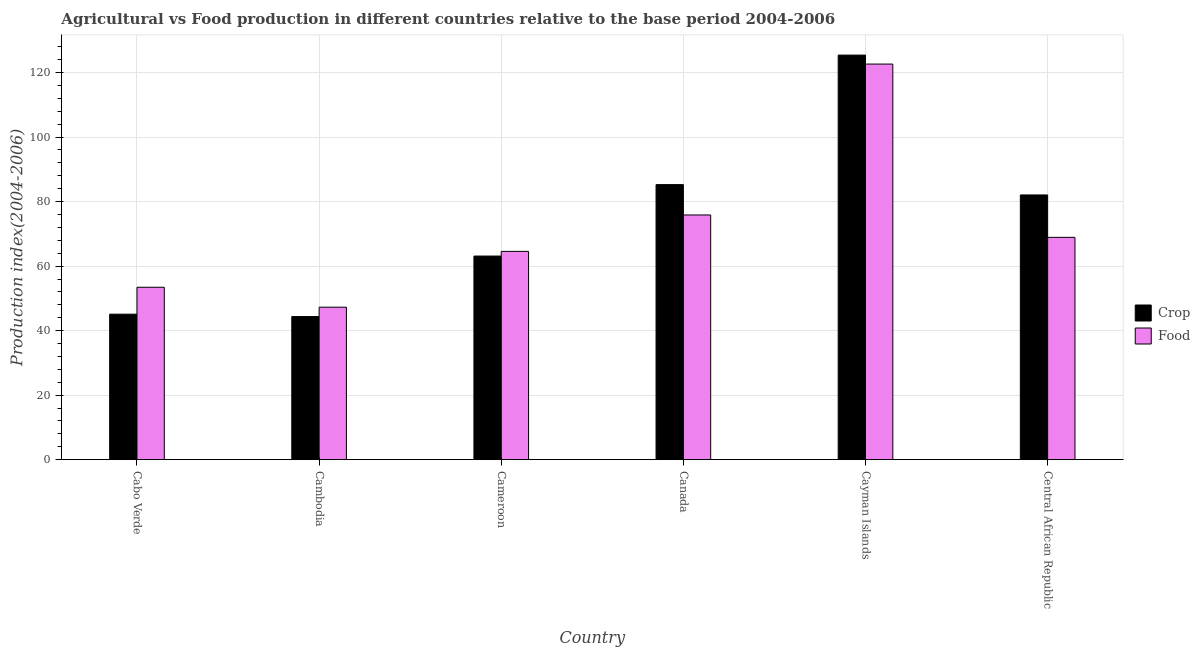How many groups of bars are there?
Make the answer very short. 6. Are the number of bars per tick equal to the number of legend labels?
Your answer should be very brief. Yes. Are the number of bars on each tick of the X-axis equal?
Your answer should be very brief. Yes. What is the label of the 1st group of bars from the left?
Offer a terse response. Cabo Verde. What is the food production index in Canada?
Provide a succinct answer. 75.85. Across all countries, what is the maximum crop production index?
Your answer should be very brief. 125.39. Across all countries, what is the minimum crop production index?
Ensure brevity in your answer.  44.36. In which country was the food production index maximum?
Your answer should be very brief. Cayman Islands. In which country was the food production index minimum?
Make the answer very short. Cambodia. What is the total crop production index in the graph?
Make the answer very short. 445.26. What is the difference between the food production index in Cambodia and that in Cameroon?
Offer a very short reply. -17.29. What is the difference between the food production index in Cambodia and the crop production index in Cabo Verde?
Make the answer very short. 2.17. What is the average crop production index per country?
Offer a terse response. 74.21. What is the difference between the crop production index and food production index in Cameroon?
Make the answer very short. -1.45. In how many countries, is the food production index greater than 24 ?
Make the answer very short. 6. What is the ratio of the food production index in Cambodia to that in Canada?
Your answer should be very brief. 0.62. Is the difference between the food production index in Cabo Verde and Central African Republic greater than the difference between the crop production index in Cabo Verde and Central African Republic?
Your response must be concise. Yes. What is the difference between the highest and the second highest crop production index?
Offer a terse response. 40.14. What is the difference between the highest and the lowest crop production index?
Give a very brief answer. 81.03. Is the sum of the food production index in Cabo Verde and Cayman Islands greater than the maximum crop production index across all countries?
Your response must be concise. Yes. What does the 1st bar from the left in Canada represents?
Provide a succinct answer. Crop. What does the 1st bar from the right in Central African Republic represents?
Give a very brief answer. Food. Are all the bars in the graph horizontal?
Your answer should be compact. No. Are the values on the major ticks of Y-axis written in scientific E-notation?
Your response must be concise. No. Does the graph contain any zero values?
Keep it short and to the point. No. Does the graph contain grids?
Your answer should be very brief. Yes. How are the legend labels stacked?
Give a very brief answer. Vertical. What is the title of the graph?
Offer a very short reply. Agricultural vs Food production in different countries relative to the base period 2004-2006. Does "Under-5(female)" appear as one of the legend labels in the graph?
Offer a very short reply. No. What is the label or title of the Y-axis?
Provide a short and direct response. Production index(2004-2006). What is the Production index(2004-2006) in Crop in Cabo Verde?
Your response must be concise. 45.1. What is the Production index(2004-2006) in Food in Cabo Verde?
Keep it short and to the point. 53.44. What is the Production index(2004-2006) in Crop in Cambodia?
Provide a succinct answer. 44.36. What is the Production index(2004-2006) of Food in Cambodia?
Keep it short and to the point. 47.27. What is the Production index(2004-2006) of Crop in Cameroon?
Offer a terse response. 63.11. What is the Production index(2004-2006) in Food in Cameroon?
Your response must be concise. 64.56. What is the Production index(2004-2006) of Crop in Canada?
Provide a short and direct response. 85.25. What is the Production index(2004-2006) of Food in Canada?
Ensure brevity in your answer.  75.85. What is the Production index(2004-2006) of Crop in Cayman Islands?
Ensure brevity in your answer.  125.39. What is the Production index(2004-2006) in Food in Cayman Islands?
Provide a short and direct response. 122.61. What is the Production index(2004-2006) of Crop in Central African Republic?
Your answer should be very brief. 82.05. What is the Production index(2004-2006) of Food in Central African Republic?
Ensure brevity in your answer.  68.91. Across all countries, what is the maximum Production index(2004-2006) of Crop?
Your answer should be very brief. 125.39. Across all countries, what is the maximum Production index(2004-2006) of Food?
Provide a succinct answer. 122.61. Across all countries, what is the minimum Production index(2004-2006) of Crop?
Give a very brief answer. 44.36. Across all countries, what is the minimum Production index(2004-2006) of Food?
Your answer should be very brief. 47.27. What is the total Production index(2004-2006) in Crop in the graph?
Ensure brevity in your answer.  445.26. What is the total Production index(2004-2006) in Food in the graph?
Keep it short and to the point. 432.64. What is the difference between the Production index(2004-2006) in Crop in Cabo Verde and that in Cambodia?
Your answer should be compact. 0.74. What is the difference between the Production index(2004-2006) in Food in Cabo Verde and that in Cambodia?
Your answer should be very brief. 6.17. What is the difference between the Production index(2004-2006) of Crop in Cabo Verde and that in Cameroon?
Keep it short and to the point. -18.01. What is the difference between the Production index(2004-2006) of Food in Cabo Verde and that in Cameroon?
Keep it short and to the point. -11.12. What is the difference between the Production index(2004-2006) in Crop in Cabo Verde and that in Canada?
Keep it short and to the point. -40.15. What is the difference between the Production index(2004-2006) in Food in Cabo Verde and that in Canada?
Offer a very short reply. -22.41. What is the difference between the Production index(2004-2006) in Crop in Cabo Verde and that in Cayman Islands?
Make the answer very short. -80.29. What is the difference between the Production index(2004-2006) in Food in Cabo Verde and that in Cayman Islands?
Provide a succinct answer. -69.17. What is the difference between the Production index(2004-2006) of Crop in Cabo Verde and that in Central African Republic?
Keep it short and to the point. -36.95. What is the difference between the Production index(2004-2006) of Food in Cabo Verde and that in Central African Republic?
Offer a terse response. -15.47. What is the difference between the Production index(2004-2006) in Crop in Cambodia and that in Cameroon?
Ensure brevity in your answer.  -18.75. What is the difference between the Production index(2004-2006) in Food in Cambodia and that in Cameroon?
Give a very brief answer. -17.29. What is the difference between the Production index(2004-2006) of Crop in Cambodia and that in Canada?
Offer a terse response. -40.89. What is the difference between the Production index(2004-2006) in Food in Cambodia and that in Canada?
Give a very brief answer. -28.58. What is the difference between the Production index(2004-2006) in Crop in Cambodia and that in Cayman Islands?
Your response must be concise. -81.03. What is the difference between the Production index(2004-2006) in Food in Cambodia and that in Cayman Islands?
Offer a very short reply. -75.34. What is the difference between the Production index(2004-2006) of Crop in Cambodia and that in Central African Republic?
Offer a terse response. -37.69. What is the difference between the Production index(2004-2006) in Food in Cambodia and that in Central African Republic?
Your answer should be very brief. -21.64. What is the difference between the Production index(2004-2006) in Crop in Cameroon and that in Canada?
Give a very brief answer. -22.14. What is the difference between the Production index(2004-2006) of Food in Cameroon and that in Canada?
Your answer should be very brief. -11.29. What is the difference between the Production index(2004-2006) in Crop in Cameroon and that in Cayman Islands?
Your answer should be compact. -62.28. What is the difference between the Production index(2004-2006) in Food in Cameroon and that in Cayman Islands?
Your answer should be very brief. -58.05. What is the difference between the Production index(2004-2006) of Crop in Cameroon and that in Central African Republic?
Ensure brevity in your answer.  -18.94. What is the difference between the Production index(2004-2006) in Food in Cameroon and that in Central African Republic?
Make the answer very short. -4.35. What is the difference between the Production index(2004-2006) in Crop in Canada and that in Cayman Islands?
Ensure brevity in your answer.  -40.14. What is the difference between the Production index(2004-2006) of Food in Canada and that in Cayman Islands?
Your response must be concise. -46.76. What is the difference between the Production index(2004-2006) in Food in Canada and that in Central African Republic?
Ensure brevity in your answer.  6.94. What is the difference between the Production index(2004-2006) in Crop in Cayman Islands and that in Central African Republic?
Ensure brevity in your answer.  43.34. What is the difference between the Production index(2004-2006) of Food in Cayman Islands and that in Central African Republic?
Ensure brevity in your answer.  53.7. What is the difference between the Production index(2004-2006) in Crop in Cabo Verde and the Production index(2004-2006) in Food in Cambodia?
Your answer should be compact. -2.17. What is the difference between the Production index(2004-2006) in Crop in Cabo Verde and the Production index(2004-2006) in Food in Cameroon?
Your answer should be very brief. -19.46. What is the difference between the Production index(2004-2006) in Crop in Cabo Verde and the Production index(2004-2006) in Food in Canada?
Offer a very short reply. -30.75. What is the difference between the Production index(2004-2006) in Crop in Cabo Verde and the Production index(2004-2006) in Food in Cayman Islands?
Ensure brevity in your answer.  -77.51. What is the difference between the Production index(2004-2006) in Crop in Cabo Verde and the Production index(2004-2006) in Food in Central African Republic?
Offer a very short reply. -23.81. What is the difference between the Production index(2004-2006) in Crop in Cambodia and the Production index(2004-2006) in Food in Cameroon?
Offer a very short reply. -20.2. What is the difference between the Production index(2004-2006) in Crop in Cambodia and the Production index(2004-2006) in Food in Canada?
Provide a succinct answer. -31.49. What is the difference between the Production index(2004-2006) of Crop in Cambodia and the Production index(2004-2006) of Food in Cayman Islands?
Offer a terse response. -78.25. What is the difference between the Production index(2004-2006) of Crop in Cambodia and the Production index(2004-2006) of Food in Central African Republic?
Offer a very short reply. -24.55. What is the difference between the Production index(2004-2006) of Crop in Cameroon and the Production index(2004-2006) of Food in Canada?
Give a very brief answer. -12.74. What is the difference between the Production index(2004-2006) of Crop in Cameroon and the Production index(2004-2006) of Food in Cayman Islands?
Keep it short and to the point. -59.5. What is the difference between the Production index(2004-2006) of Crop in Canada and the Production index(2004-2006) of Food in Cayman Islands?
Keep it short and to the point. -37.36. What is the difference between the Production index(2004-2006) of Crop in Canada and the Production index(2004-2006) of Food in Central African Republic?
Provide a succinct answer. 16.34. What is the difference between the Production index(2004-2006) of Crop in Cayman Islands and the Production index(2004-2006) of Food in Central African Republic?
Offer a terse response. 56.48. What is the average Production index(2004-2006) of Crop per country?
Your answer should be very brief. 74.21. What is the average Production index(2004-2006) in Food per country?
Ensure brevity in your answer.  72.11. What is the difference between the Production index(2004-2006) in Crop and Production index(2004-2006) in Food in Cabo Verde?
Offer a terse response. -8.34. What is the difference between the Production index(2004-2006) in Crop and Production index(2004-2006) in Food in Cambodia?
Your response must be concise. -2.91. What is the difference between the Production index(2004-2006) in Crop and Production index(2004-2006) in Food in Cameroon?
Your response must be concise. -1.45. What is the difference between the Production index(2004-2006) of Crop and Production index(2004-2006) of Food in Canada?
Offer a very short reply. 9.4. What is the difference between the Production index(2004-2006) in Crop and Production index(2004-2006) in Food in Cayman Islands?
Ensure brevity in your answer.  2.78. What is the difference between the Production index(2004-2006) of Crop and Production index(2004-2006) of Food in Central African Republic?
Keep it short and to the point. 13.14. What is the ratio of the Production index(2004-2006) of Crop in Cabo Verde to that in Cambodia?
Ensure brevity in your answer.  1.02. What is the ratio of the Production index(2004-2006) in Food in Cabo Verde to that in Cambodia?
Offer a terse response. 1.13. What is the ratio of the Production index(2004-2006) of Crop in Cabo Verde to that in Cameroon?
Your answer should be very brief. 0.71. What is the ratio of the Production index(2004-2006) in Food in Cabo Verde to that in Cameroon?
Ensure brevity in your answer.  0.83. What is the ratio of the Production index(2004-2006) in Crop in Cabo Verde to that in Canada?
Your response must be concise. 0.53. What is the ratio of the Production index(2004-2006) in Food in Cabo Verde to that in Canada?
Provide a short and direct response. 0.7. What is the ratio of the Production index(2004-2006) of Crop in Cabo Verde to that in Cayman Islands?
Your answer should be very brief. 0.36. What is the ratio of the Production index(2004-2006) in Food in Cabo Verde to that in Cayman Islands?
Offer a terse response. 0.44. What is the ratio of the Production index(2004-2006) of Crop in Cabo Verde to that in Central African Republic?
Keep it short and to the point. 0.55. What is the ratio of the Production index(2004-2006) of Food in Cabo Verde to that in Central African Republic?
Your answer should be compact. 0.78. What is the ratio of the Production index(2004-2006) in Crop in Cambodia to that in Cameroon?
Provide a short and direct response. 0.7. What is the ratio of the Production index(2004-2006) of Food in Cambodia to that in Cameroon?
Offer a terse response. 0.73. What is the ratio of the Production index(2004-2006) of Crop in Cambodia to that in Canada?
Provide a short and direct response. 0.52. What is the ratio of the Production index(2004-2006) of Food in Cambodia to that in Canada?
Your response must be concise. 0.62. What is the ratio of the Production index(2004-2006) of Crop in Cambodia to that in Cayman Islands?
Provide a succinct answer. 0.35. What is the ratio of the Production index(2004-2006) of Food in Cambodia to that in Cayman Islands?
Ensure brevity in your answer.  0.39. What is the ratio of the Production index(2004-2006) of Crop in Cambodia to that in Central African Republic?
Your answer should be very brief. 0.54. What is the ratio of the Production index(2004-2006) in Food in Cambodia to that in Central African Republic?
Keep it short and to the point. 0.69. What is the ratio of the Production index(2004-2006) in Crop in Cameroon to that in Canada?
Provide a short and direct response. 0.74. What is the ratio of the Production index(2004-2006) in Food in Cameroon to that in Canada?
Keep it short and to the point. 0.85. What is the ratio of the Production index(2004-2006) in Crop in Cameroon to that in Cayman Islands?
Give a very brief answer. 0.5. What is the ratio of the Production index(2004-2006) of Food in Cameroon to that in Cayman Islands?
Ensure brevity in your answer.  0.53. What is the ratio of the Production index(2004-2006) in Crop in Cameroon to that in Central African Republic?
Provide a succinct answer. 0.77. What is the ratio of the Production index(2004-2006) of Food in Cameroon to that in Central African Republic?
Provide a short and direct response. 0.94. What is the ratio of the Production index(2004-2006) in Crop in Canada to that in Cayman Islands?
Offer a terse response. 0.68. What is the ratio of the Production index(2004-2006) in Food in Canada to that in Cayman Islands?
Your answer should be compact. 0.62. What is the ratio of the Production index(2004-2006) of Crop in Canada to that in Central African Republic?
Your answer should be very brief. 1.04. What is the ratio of the Production index(2004-2006) of Food in Canada to that in Central African Republic?
Give a very brief answer. 1.1. What is the ratio of the Production index(2004-2006) in Crop in Cayman Islands to that in Central African Republic?
Offer a very short reply. 1.53. What is the ratio of the Production index(2004-2006) of Food in Cayman Islands to that in Central African Republic?
Offer a terse response. 1.78. What is the difference between the highest and the second highest Production index(2004-2006) in Crop?
Provide a succinct answer. 40.14. What is the difference between the highest and the second highest Production index(2004-2006) in Food?
Provide a short and direct response. 46.76. What is the difference between the highest and the lowest Production index(2004-2006) in Crop?
Keep it short and to the point. 81.03. What is the difference between the highest and the lowest Production index(2004-2006) of Food?
Provide a short and direct response. 75.34. 